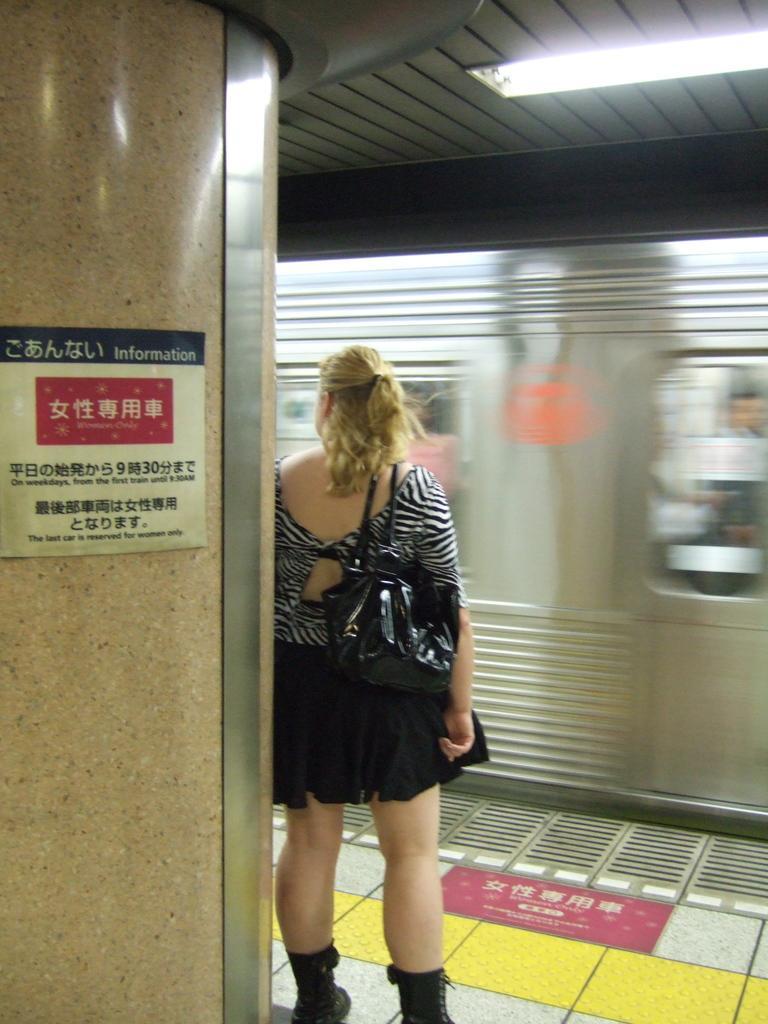In one or two sentences, can you explain what this image depicts? In this image there is a woman standing near the train. There is a pillar on the left side. There is a light in the top roof. 